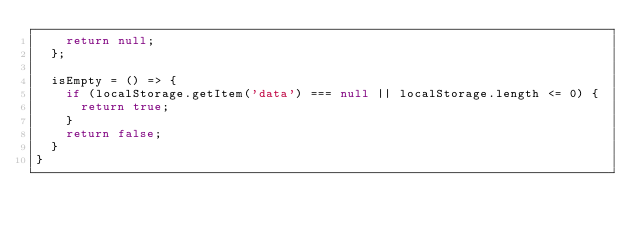Convert code to text. <code><loc_0><loc_0><loc_500><loc_500><_JavaScript_>    return null;
  };

  isEmpty = () => {
    if (localStorage.getItem('data') === null || localStorage.length <= 0) {
      return true;
    }
    return false;
  }
}
</code> 